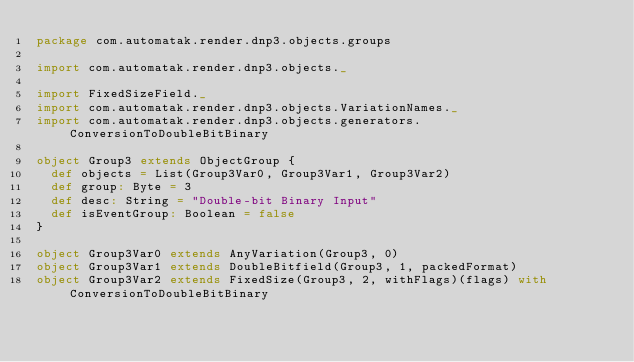Convert code to text. <code><loc_0><loc_0><loc_500><loc_500><_Scala_>package com.automatak.render.dnp3.objects.groups

import com.automatak.render.dnp3.objects._

import FixedSizeField._
import com.automatak.render.dnp3.objects.VariationNames._
import com.automatak.render.dnp3.objects.generators.ConversionToDoubleBitBinary

object Group3 extends ObjectGroup {
  def objects = List(Group3Var0, Group3Var1, Group3Var2)
  def group: Byte = 3
  def desc: String = "Double-bit Binary Input"
  def isEventGroup: Boolean = false
}

object Group3Var0 extends AnyVariation(Group3, 0)
object Group3Var1 extends DoubleBitfield(Group3, 1, packedFormat)
object Group3Var2 extends FixedSize(Group3, 2, withFlags)(flags) with ConversionToDoubleBitBinary
</code> 